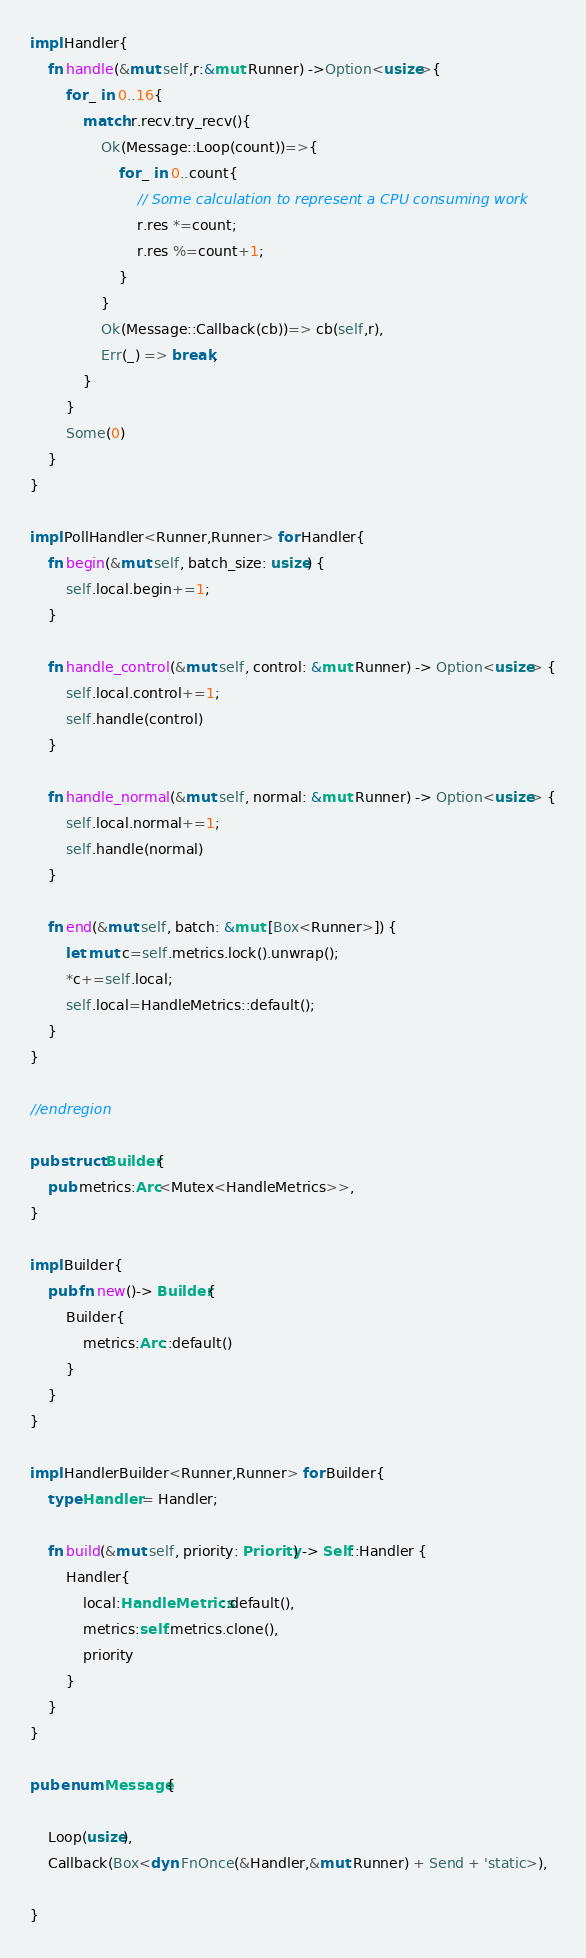Convert code to text. <code><loc_0><loc_0><loc_500><loc_500><_Rust_>
impl Handler{
    fn handle(&mut self,r:&mut Runner) ->Option<usize>{
        for _ in 0..16{
            match r.recv.try_recv(){
                Ok(Message::Loop(count))=>{
                    for _ in 0..count{
                        // Some calculation to represent a CPU consuming work
                        r.res *=count;
                        r.res %=count+1;
                    }
                }
                Ok(Message::Callback(cb))=> cb(self,r),
                Err(_) => break,
            }
        }
        Some(0)
    }
}

impl PollHandler<Runner,Runner> for Handler{
    fn begin(&mut self, batch_size: usize) {
        self.local.begin+=1;
    }

    fn handle_control(&mut self, control: &mut Runner) -> Option<usize> {
        self.local.control+=1;
        self.handle(control)
    }

    fn handle_normal(&mut self, normal: &mut Runner) -> Option<usize> {
        self.local.normal+=1;
        self.handle(normal)
    }

    fn end(&mut self, batch: &mut [Box<Runner>]) {
        let mut c=self.metrics.lock().unwrap();
        *c+=self.local;
        self.local=HandleMetrics::default();
    }
}

//endregion

pub struct Builder{
    pub metrics:Arc<Mutex<HandleMetrics>>,
}

impl Builder{
    pub fn new()-> Builder{
        Builder{
            metrics:Arc::default()
        }
    }
}

impl HandlerBuilder<Runner,Runner> for Builder{
    type Handler = Handler;

    fn build(&mut self, priority: Priority) -> Self::Handler {
        Handler{
            local:HandleMetrics::default(),
            metrics:self.metrics.clone(),
            priority
        }
    }
}

pub enum Message{

    Loop(usize),
    Callback(Box<dyn FnOnce(&Handler,&mut Runner) + Send + 'static>),

}</code> 